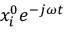Convert formula to latex. <formula><loc_0><loc_0><loc_500><loc_500>x _ { i } ^ { 0 } e ^ { - j { \omega } t }</formula> 